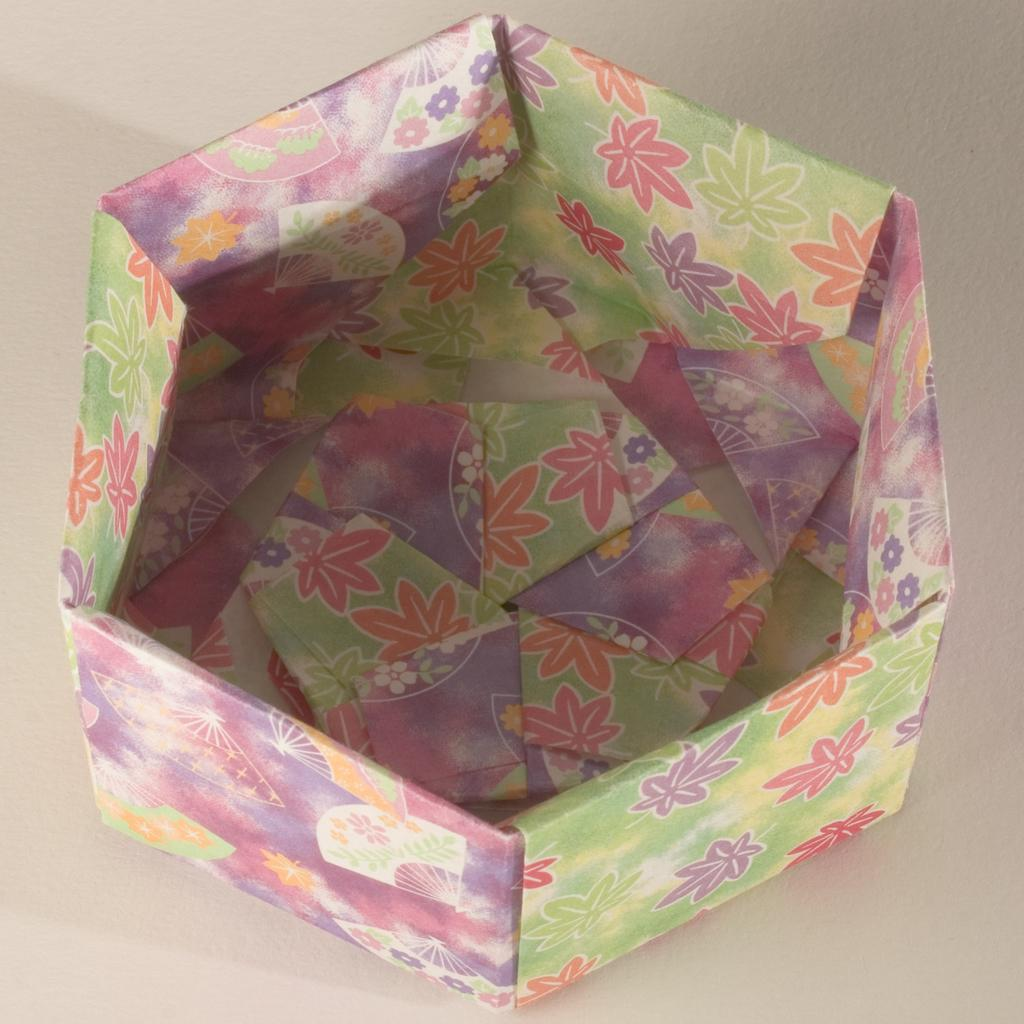What is the main subject in the middle of the image? There is a basket decoration with papers in the middle of the image. What can be seen at the bottom of the image? There is a floor visible at the bottom of the image. Are there any cobwebs visible on the stage in the image? There is no stage or cobwebs present in the image; it features a basket decoration with papers and a floor. 